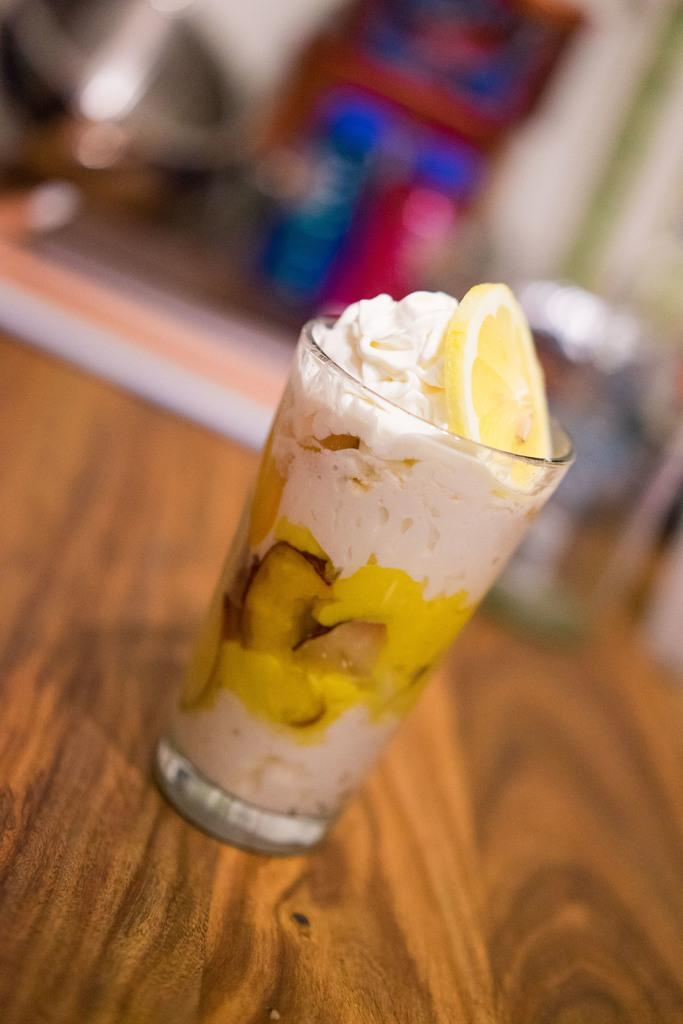What piece of furniture is present in the image? There is a table in the image. How is the table depicted in the image? The table is truncated towards the bottom of the image. What is placed on the table? There is a glass on the table. What is inside the glass? There is a drink in the glass. Can you describe the background of the image? The background of the image is blurred. What type of pen is visible on the table in the image? There is no pen present on the table in the image. Is there a cabbage or tomatoes on the table in the image? No, there is no cabbage or tomatoes on the table in the image. 